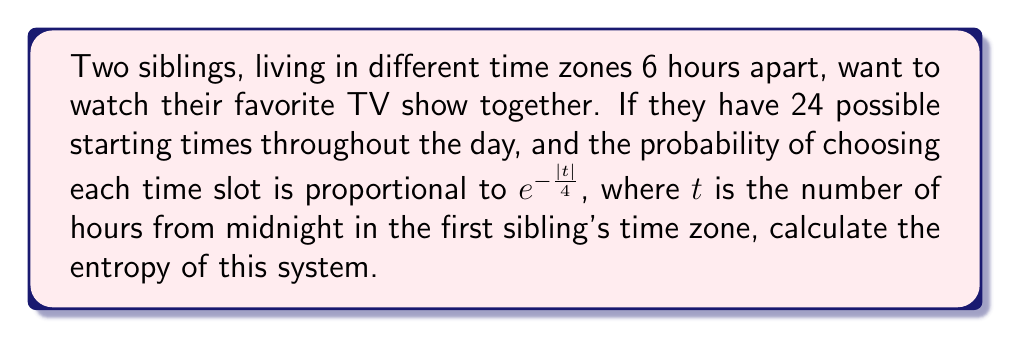Provide a solution to this math problem. 1. Let's first calculate the partition function $Z$:
   $$Z = \sum_{t=0}^{23} e^{-\frac{|t|}{4}}$$

2. Calculate the probabilities for each time slot:
   $$p_t = \frac{1}{Z} e^{-\frac{|t|}{4}}$$

3. The entropy $S$ is given by:
   $$S = -k_B \sum_{t=0}^{23} p_t \ln p_t$$
   where $k_B$ is Boltzmann's constant.

4. Substituting the expression for $p_t$:
   $$S = -k_B \sum_{t=0}^{23} \frac{1}{Z} e^{-\frac{|t|}{4}} \ln \left(\frac{1}{Z} e^{-\frac{|t|}{4}}\right)$$

5. Simplify:
   $$S = -k_B \sum_{t=0}^{23} \frac{1}{Z} e^{-\frac{|t|}{4}} \left(-\ln Z - \frac{|t|}{4}\right)$$

6. Distribute:
   $$S = k_B \ln Z \sum_{t=0}^{23} \frac{1}{Z} e^{-\frac{|t|}{4}} + \frac{k_B}{4Z} \sum_{t=0}^{23} |t| e^{-\frac{|t|}{4}}$$

7. Recognize that the first sum equals 1:
   $$S = k_B \ln Z + \frac{k_B}{4Z} \sum_{t=0}^{23} |t| e^{-\frac{|t|}{4}}$$

8. The final expression for entropy is:
   $$S = k_B \left(\ln Z + \frac{1}{4Z} \sum_{t=0}^{23} |t| e^{-\frac{|t|}{4}}\right)$$
Answer: $$S = k_B \left(\ln Z + \frac{1}{4Z} \sum_{t=0}^{23} |t| e^{-\frac{|t|}{4}}\right)$$ 